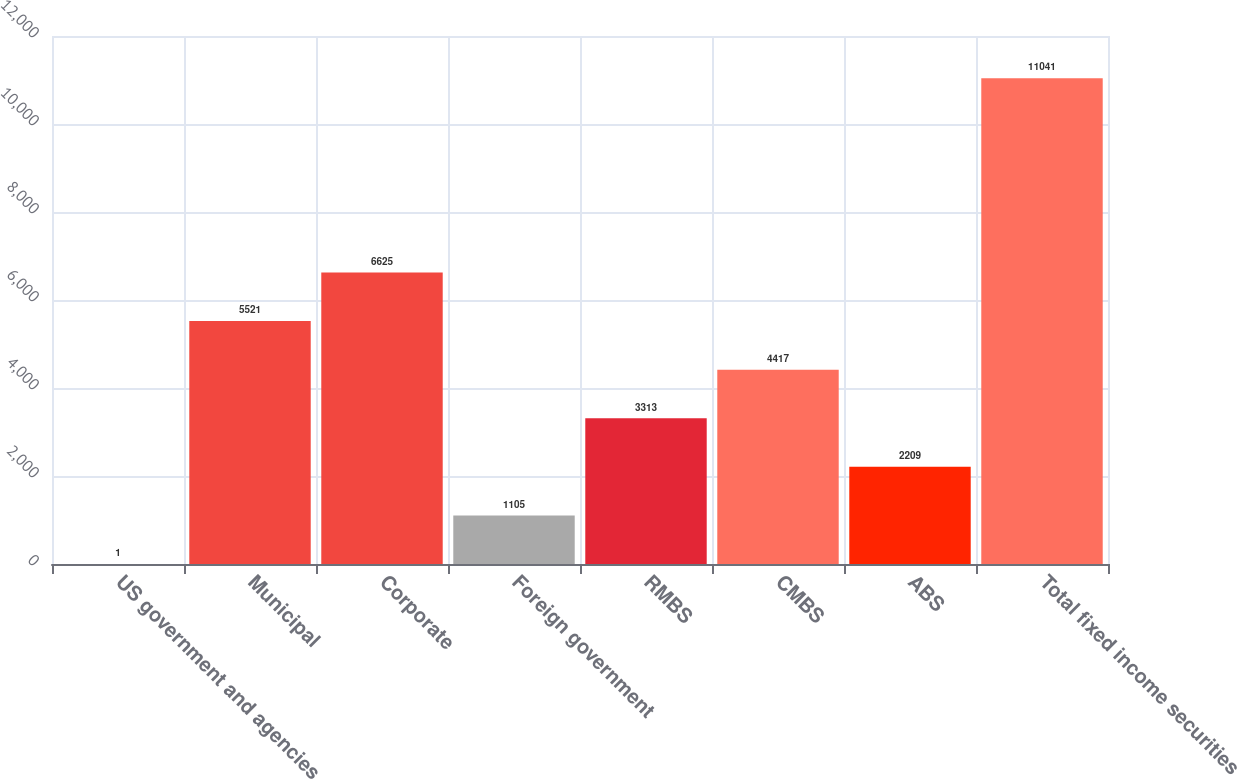<chart> <loc_0><loc_0><loc_500><loc_500><bar_chart><fcel>US government and agencies<fcel>Municipal<fcel>Corporate<fcel>Foreign government<fcel>RMBS<fcel>CMBS<fcel>ABS<fcel>Total fixed income securities<nl><fcel>1<fcel>5521<fcel>6625<fcel>1105<fcel>3313<fcel>4417<fcel>2209<fcel>11041<nl></chart> 